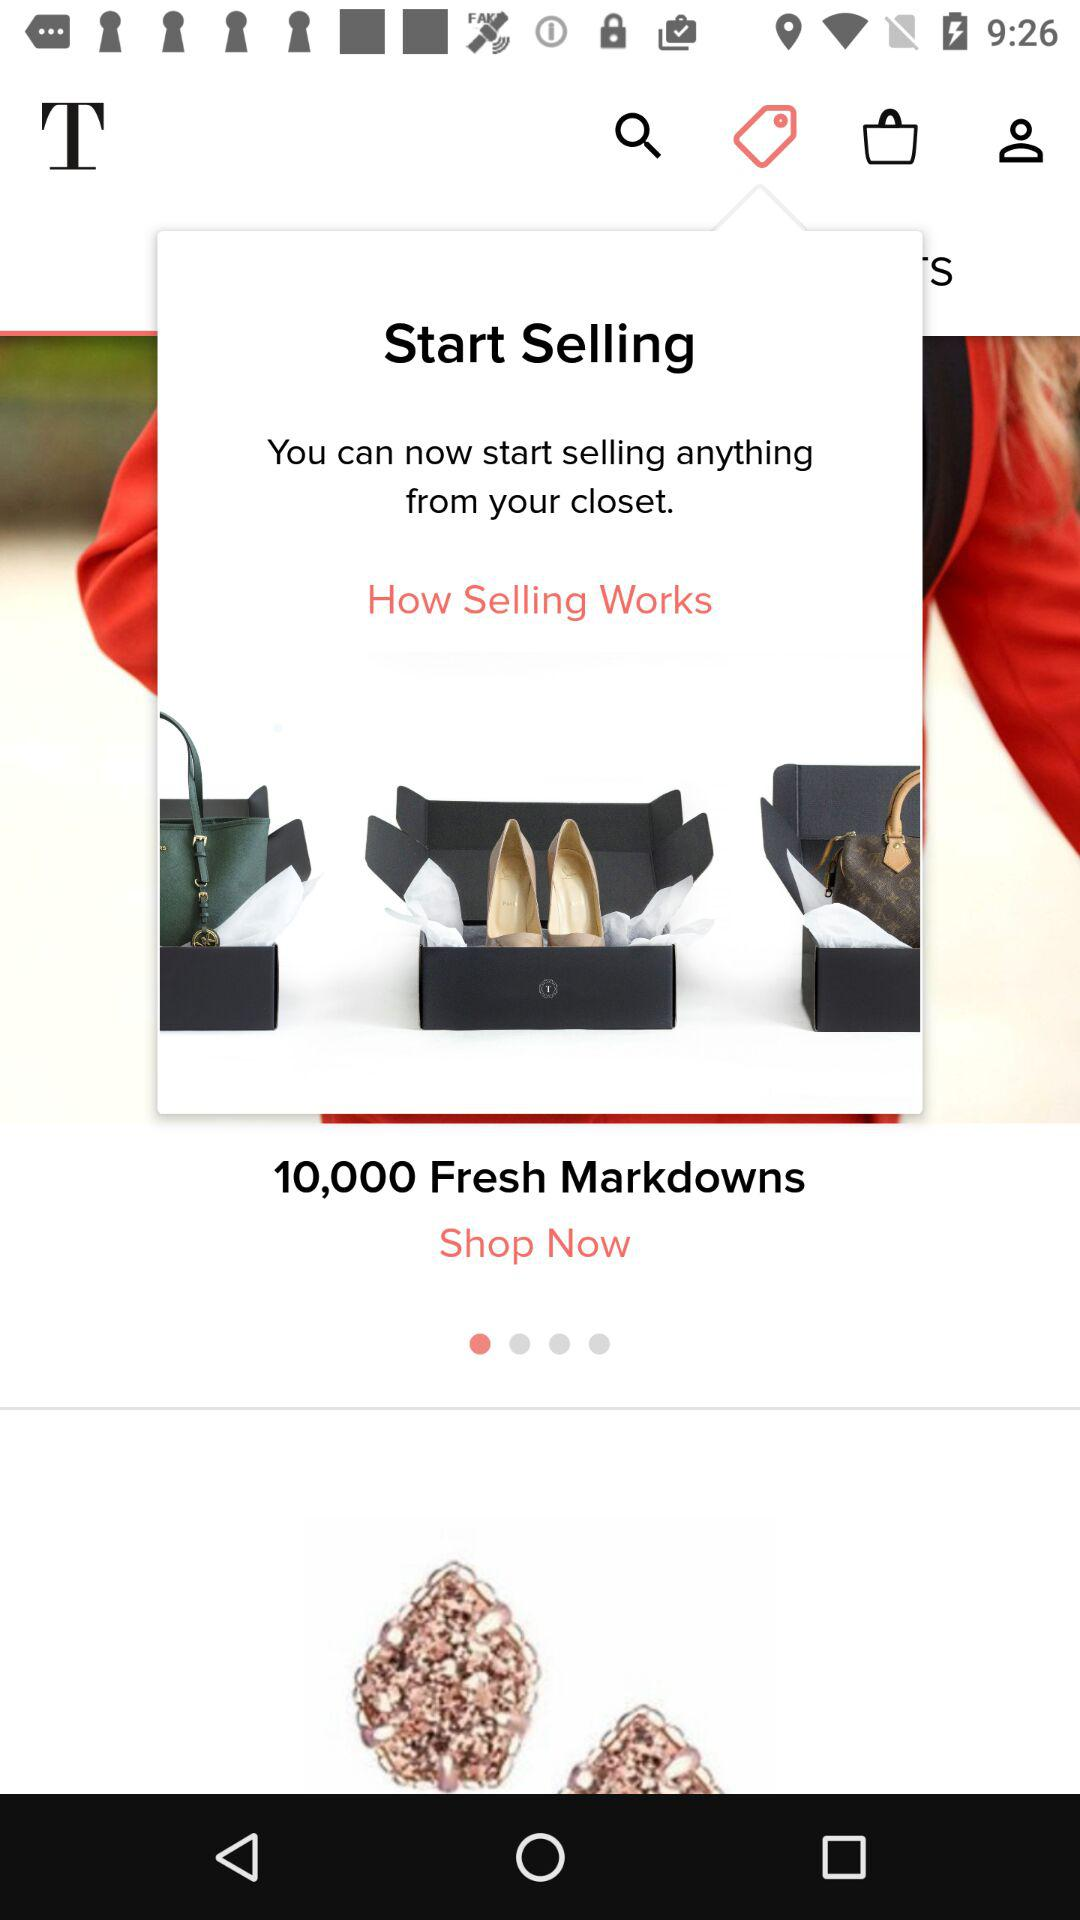How many fresh markdowns are there? There are 10,000 fresh markdowns. 